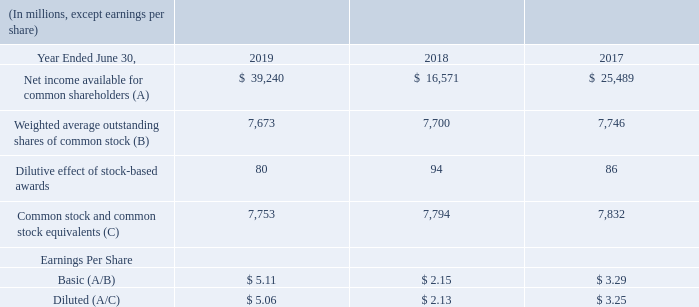NOTE 2 — EARNINGS PER SHARE
Basic earnings per share (“EPS”) is computed based on the weighted average number of shares of common stock outstanding during the period. Diluted EPS is computed based on the weighted average number of shares of common stock plus the effect of dilutive potential common shares outstanding during the period using the treasury stock method. Dilutive potential common shares include outstanding stock options and stock awards.
The components of basic and diluted EPS were as follows:
Anti-dilutive stock-based awards excluded from the calculations of diluted EPS were immaterial during the periods presented.
How is basic earnings per share computed? Basic earnings per share (“eps”) is computed based on the weighted average number of shares of common stock outstanding during the period. How is diluted earnings per share computed? Diluted eps is computed based on the weighted average number of shares of common stock plus the effect of dilutive potential common shares outstanding during the period using the treasury stock method. How much was the net income available for common shareholders in 2019?
Answer scale should be: million. 39,240. What was the average basic earnings per share over the 3 year period from 2017 to 2019? (5.11+2.15+3.29)/3 
Answer: 3.52. What was the % change in net income available for common shareholders from 2018 to 2019?
Answer scale should be: percent. (39,240-16,571)/16,571
Answer: 136.8. What was the % change in the common stock and stock equivalents from 2018 to 2019?
Answer scale should be: percent. (7,753-7,794)/7,794
Answer: -0.53. 